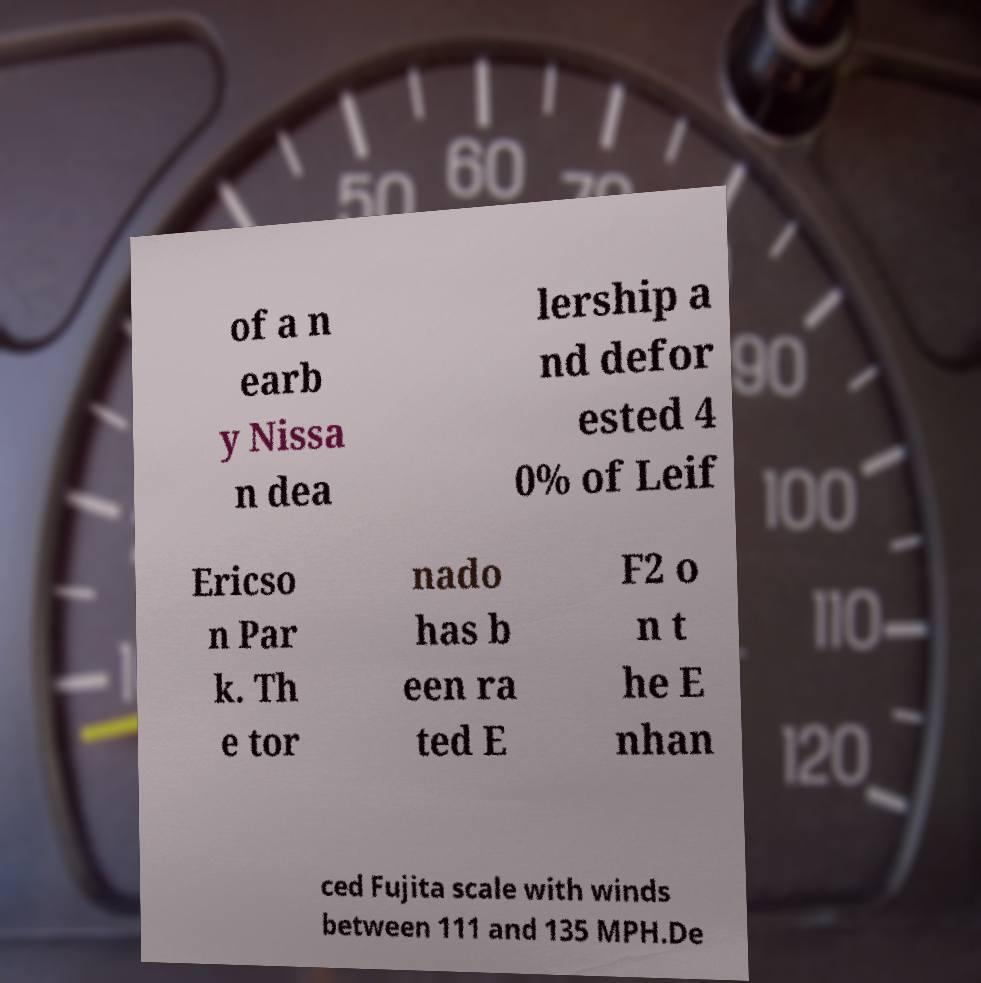There's text embedded in this image that I need extracted. Can you transcribe it verbatim? of a n earb y Nissa n dea lership a nd defor ested 4 0% of Leif Ericso n Par k. Th e tor nado has b een ra ted E F2 o n t he E nhan ced Fujita scale with winds between 111 and 135 MPH.De 